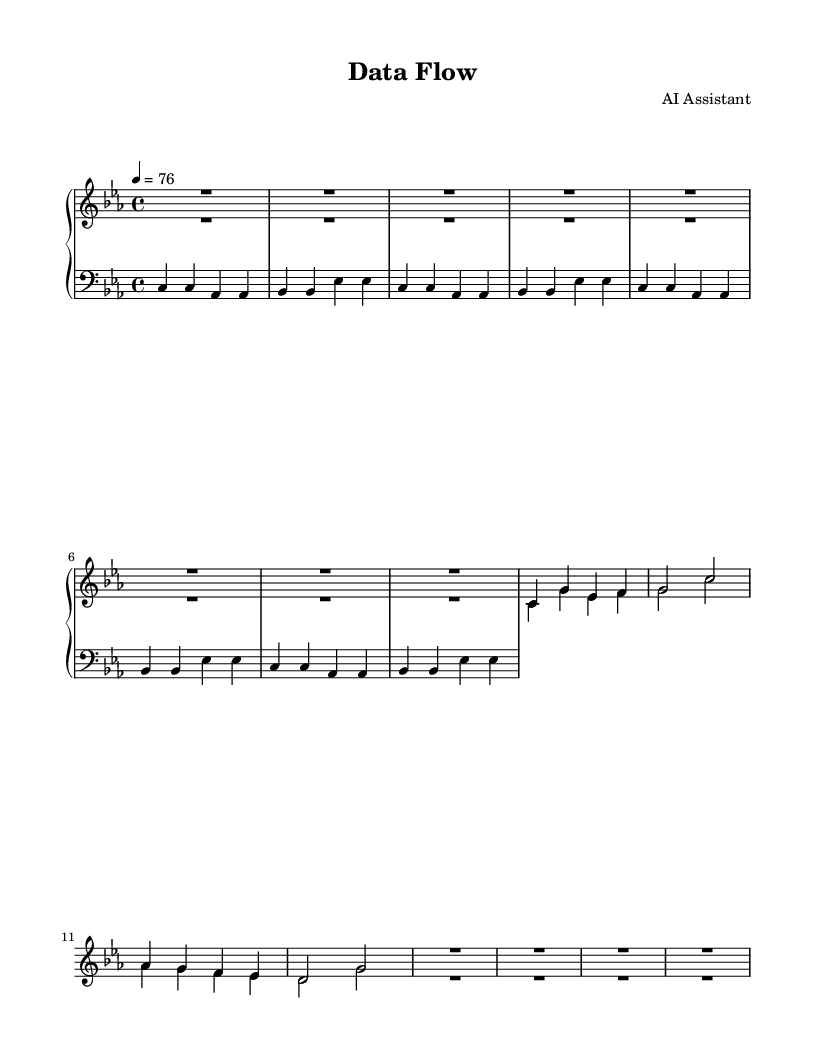What is the key signature of this music? The key signature indicated in the music is C minor, which has three flats: B-flat, E-flat, and A-flat. This can be determined from the symbols at the beginning of the staff where the key flat signs are placed.
Answer: C minor What is the time signature of this music? The time signature is found at the beginning of the piece, where it is indicated as 4/4, meaning there are four beats per measure, and the quarter note gets one beat. This is noted beside the key signature.
Answer: 4/4 What is the tempo marking of this music? The tempo marking is placed at the beginning of the score, indicating 4 = 76, which means a quarter note should be played at a speed of 76 beats per minute. This can be seen in the tempo directive section.
Answer: 76 How many measures are there in the music? By counting the number of groupings of notes separated by vertical lines in the score, we can find the total number of measures. There are a total of 8 measures in this piece.
Answer: 8 What are the two main instruments used in the upper staff? The upper staff includes voices labeled as "synthPad" and "electricPiano," which represent the two main instruments used to create the atmospheric electronic sound. This can be identified from the labels above each voice part in the upper staff.
Answer: synthPad and electricPiano What is the rhythmic value of the first rest in the synthPad part? The first rest in the synthPad part is represented as a whole rest, which is indicated by the symbol occupying the entirety of a measure. This can be recognized by the absence of note heads for the entire duration of the initial measure.
Answer: whole rest 